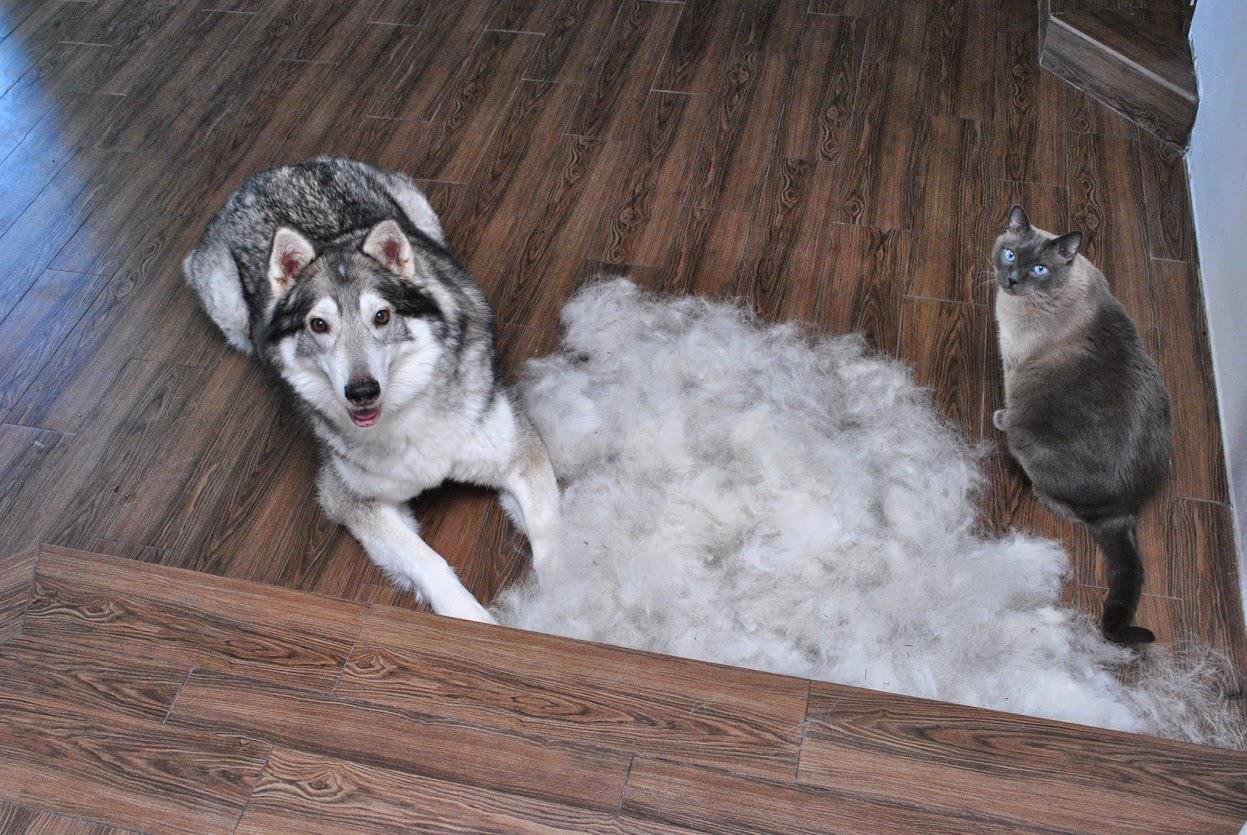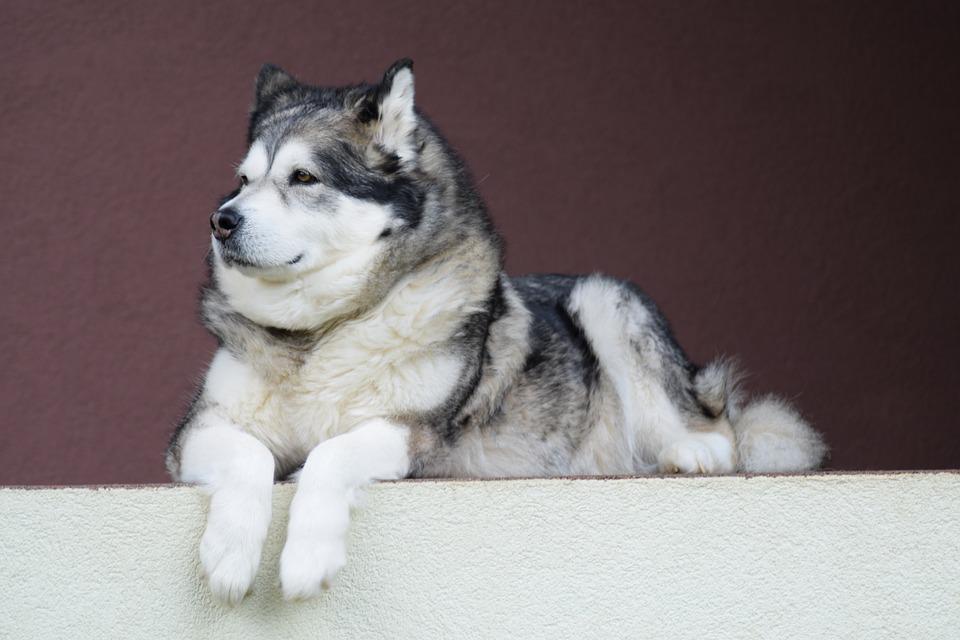The first image is the image on the left, the second image is the image on the right. Considering the images on both sides, is "Four or more dogs can be seen." valid? Answer yes or no. No. The first image is the image on the left, the second image is the image on the right. Examine the images to the left and right. Is the description "There is freshly cut hair on the ground." accurate? Answer yes or no. Yes. 